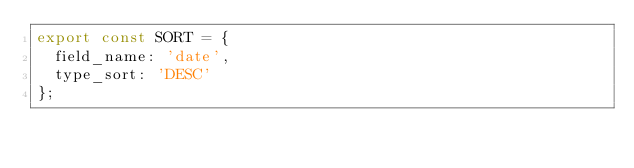<code> <loc_0><loc_0><loc_500><loc_500><_TypeScript_>export const SORT = {
  field_name: 'date',
  type_sort: 'DESC'
};
</code> 